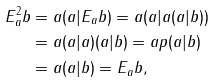<formula> <loc_0><loc_0><loc_500><loc_500>E _ { a } ^ { 2 } b & = a ( a | E _ { a } b ) = a ( a | a ( a | b ) ) \\ & = a ( a | a ) ( a | b ) = a p ( a | b ) \\ & = a ( a | b ) = E _ { a } b ,</formula> 